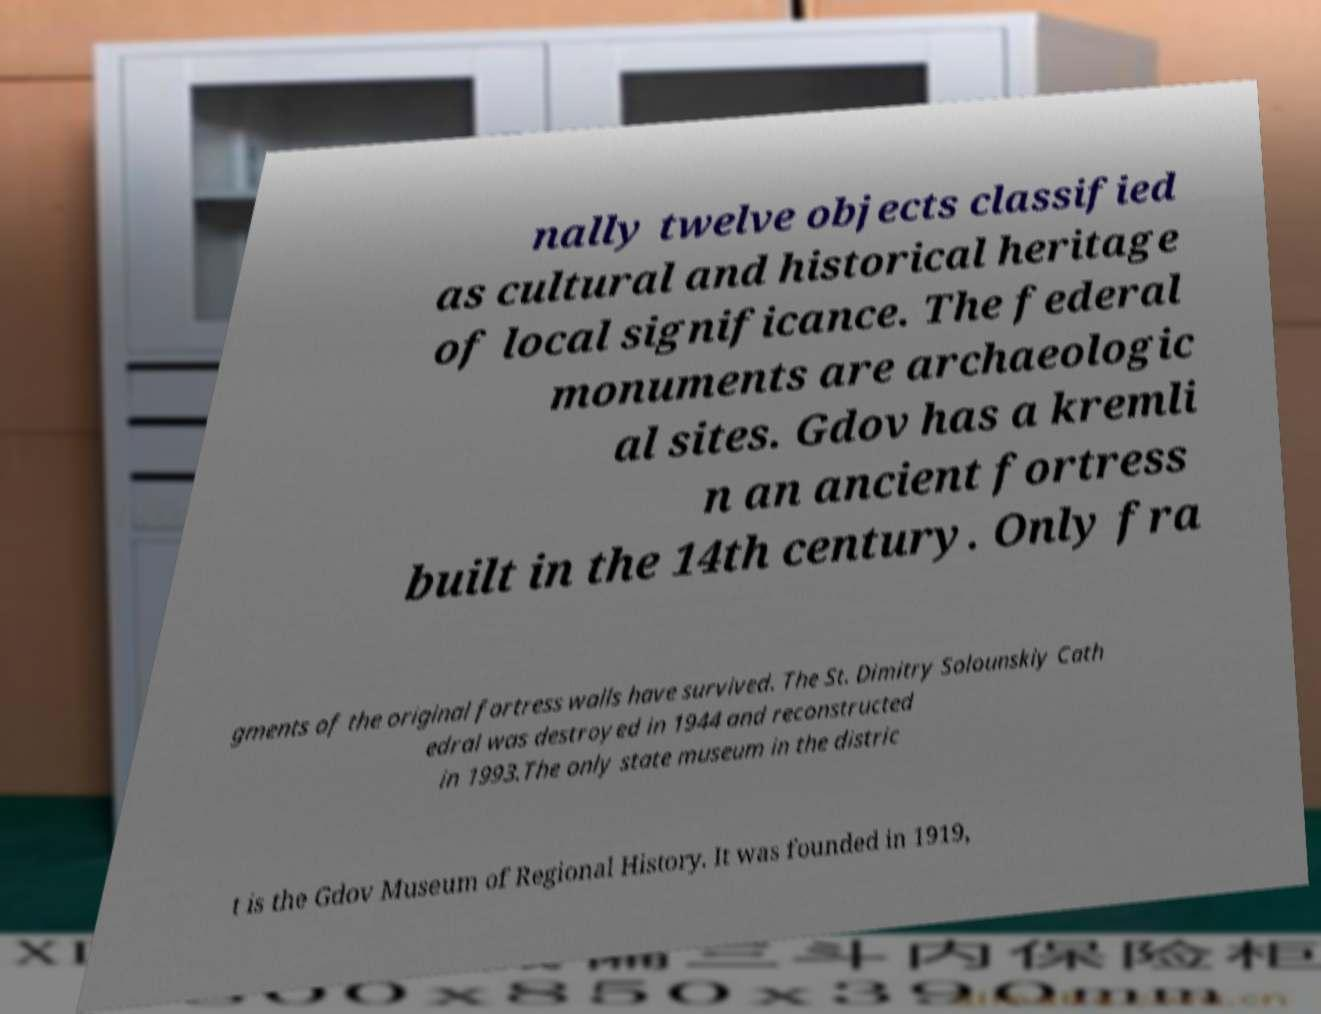Can you read and provide the text displayed in the image?This photo seems to have some interesting text. Can you extract and type it out for me? nally twelve objects classified as cultural and historical heritage of local significance. The federal monuments are archaeologic al sites. Gdov has a kremli n an ancient fortress built in the 14th century. Only fra gments of the original fortress walls have survived. The St. Dimitry Solounskiy Cath edral was destroyed in 1944 and reconstructed in 1993.The only state museum in the distric t is the Gdov Museum of Regional History. It was founded in 1919, 